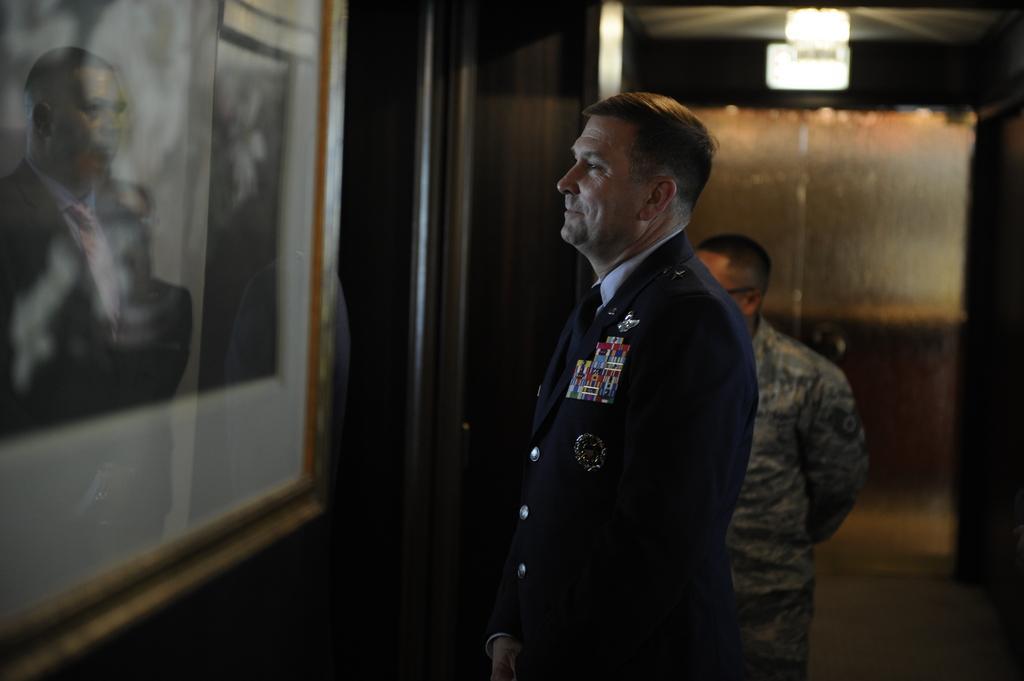Can you describe this image briefly? In this picture I can see there is a man standing and he is wearing a uniform and is smiling, he is looking at the left side. There is another person in the backdrop, there are lights attached to the ceiling. 